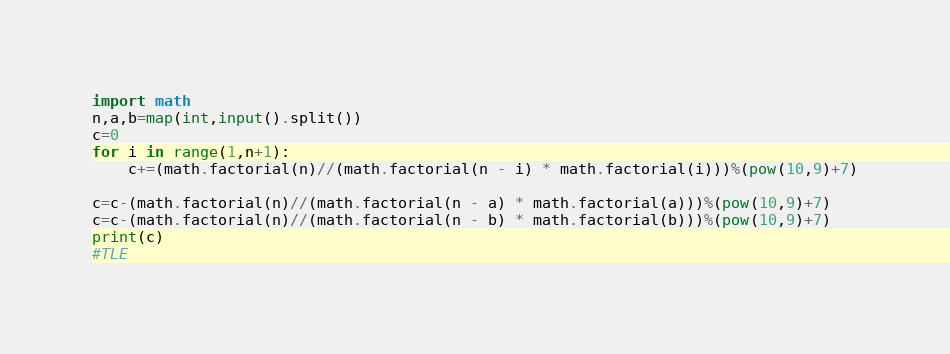<code> <loc_0><loc_0><loc_500><loc_500><_Python_>import math
n,a,b=map(int,input().split())
c=0
for i in range(1,n+1):
    c+=(math.factorial(n)//(math.factorial(n - i) * math.factorial(i)))%(pow(10,9)+7)

c=c-(math.factorial(n)//(math.factorial(n - a) * math.factorial(a)))%(pow(10,9)+7)
c=c-(math.factorial(n)//(math.factorial(n - b) * math.factorial(b)))%(pow(10,9)+7)
print(c)
#TLE</code> 